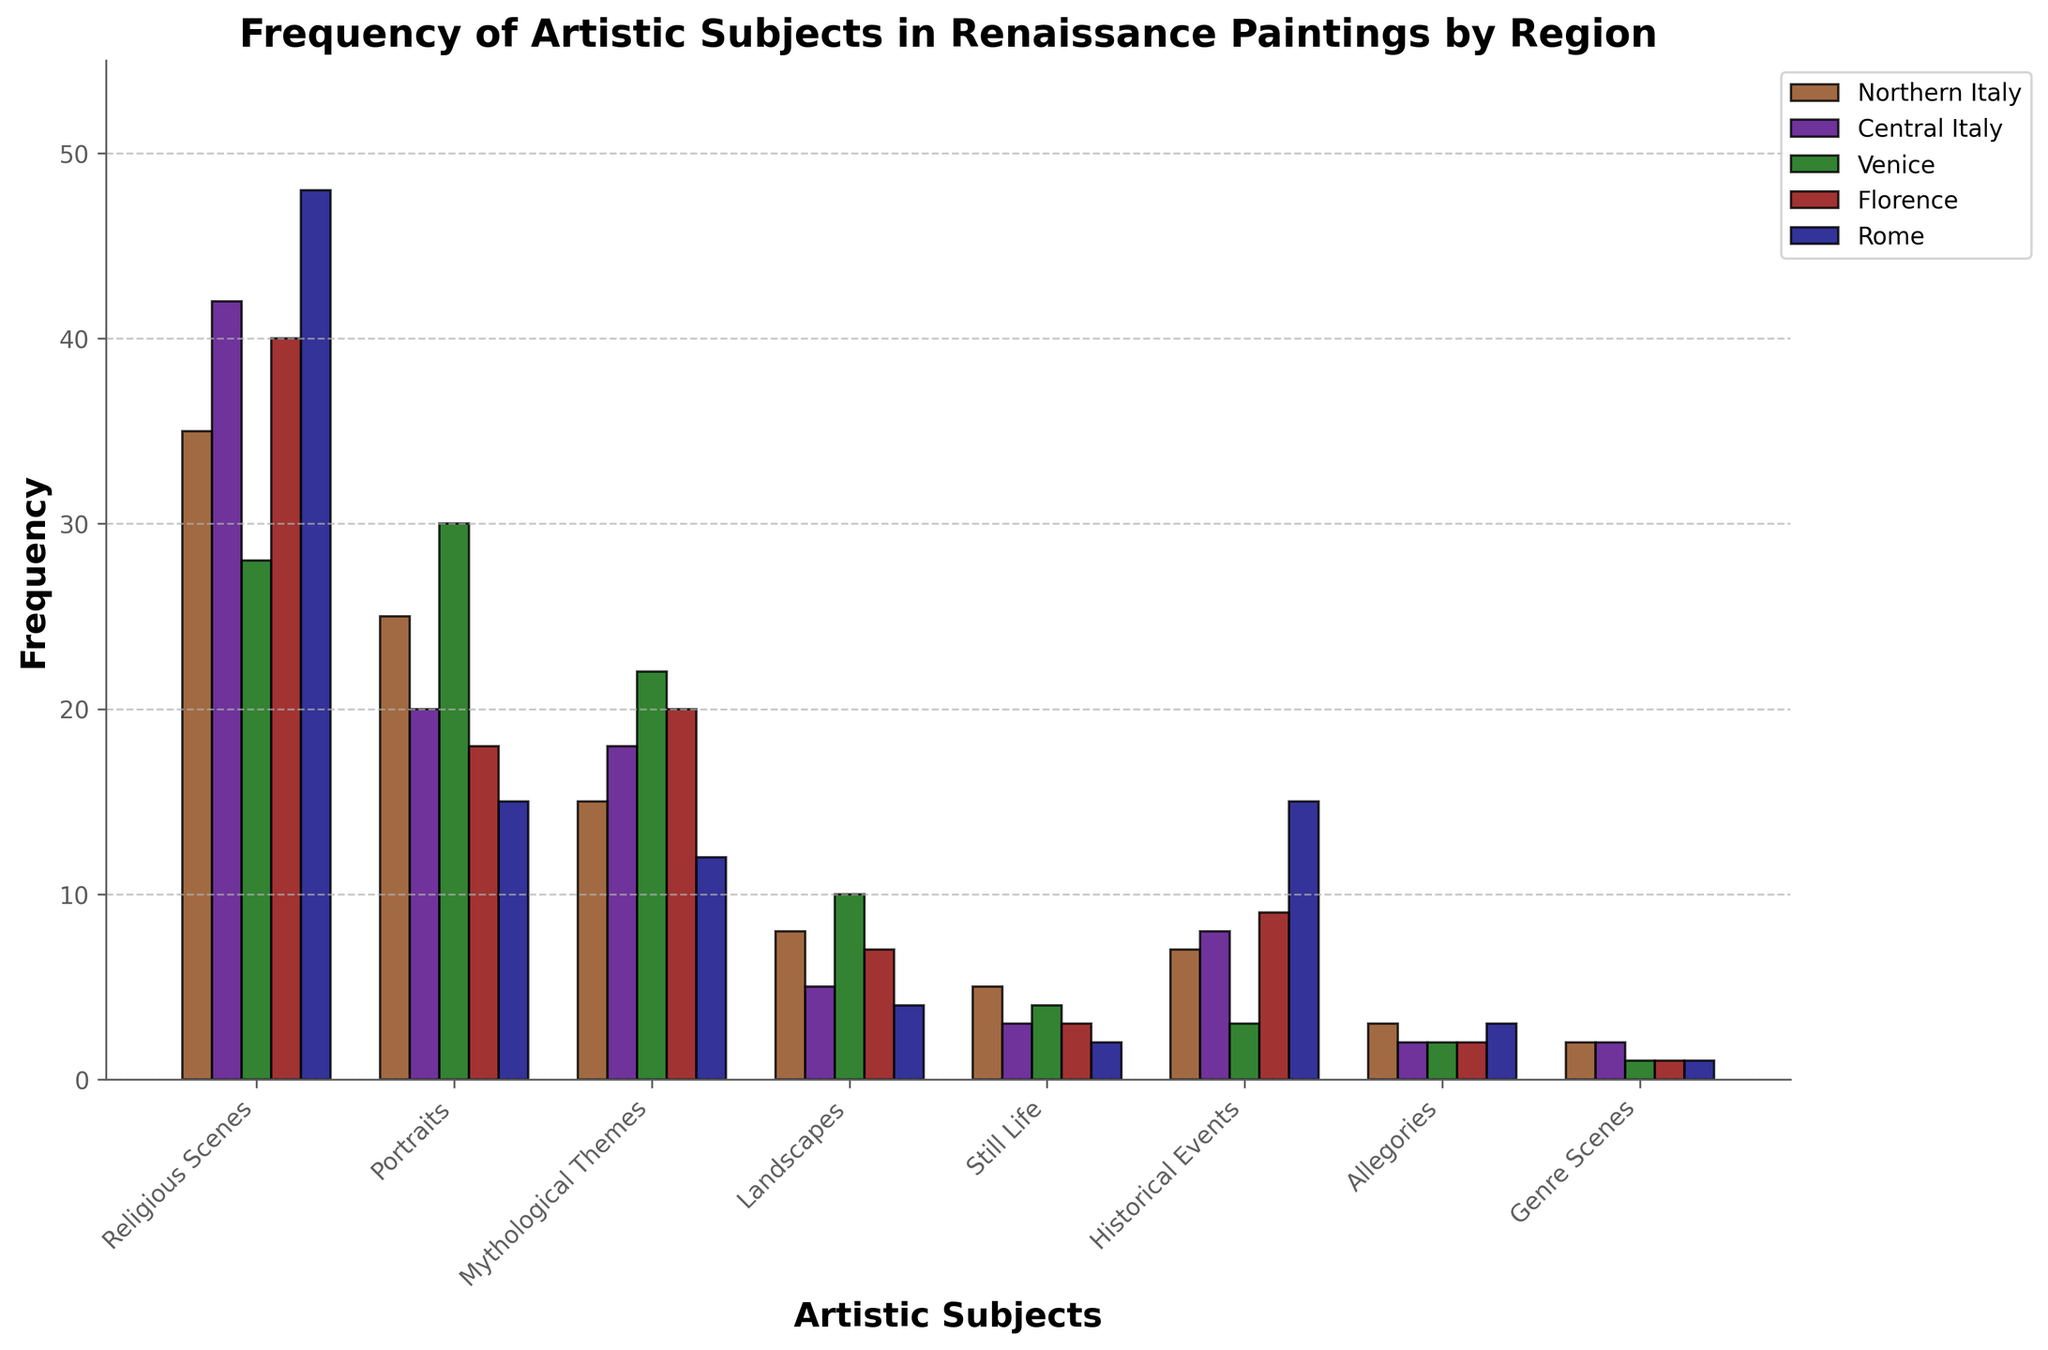What is the most frequently depicted artistic subject in Northern Italy? To find the most depicted artistic subject in Northern Italy, look for the tallest bar in the "Northern Italy" section of the chart. The highest bar corresponds to "Religious Scenes".
Answer: Religious Scenes Which region has the closest frequency of Still Life paintings to Rome? To determine which region has a close frequency of Still Life paintings to Rome, compare the height of the Still Life bars for all regions. Rome has a frequency of 2, and Central Italy also has a bar with a frequency of 3, which is the closest.
Answer: Central Italy What is the total frequency of Historical Events in Central Italy and Rome combined? To find the combined frequency, add the frequency of Historical Events in Central Italy (8) and Rome (15): 8 + 15 = 23.
Answer: 23 Which region depicts the fewest Genre Scenes? Check the height of the bars corresponding to Genre Scenes in all regions. Each region has a bar, but Venice, Florence, and Rome all depict 1 Genre Scene each, which is the fewest.
Answer: Venice, Florence, Rome What is the difference in frequency between Portraits and Landscapes in Venice? To determine the difference, find the heights of the bars for Portraits (30) and Landscapes (10) in Venice and subtract the smaller from the larger: 30 - 10 = 20.
Answer: 20 How many more Religious Scenes are depicted in Rome compared to Venice? Compare the frequency of Religious Scenes in Rome (48) and Venice (28) by subtracting the smaller value from the larger: 48 - 28 = 20.
Answer: 20 Which subject is consistently least depicted across regions? Look for the shortest bar for each region to identify the subject depicted the least. "Genre Scenes" generally has the lowest frequency across all regions.
Answer: Genre Scenes Which region has the highest total frequency of artistic subjects across all categories? Sum the frequencies of all subjects for each region and compare. The sum for Rome (48 + 15 + 12 + 4 + 2 + 15 + 3 + 1 = 100) is the highest among all regions.
Answer: Rome Which two regions have the same frequency of Artistic Subjects (same overall height) for the subject Allegories? Compare the heights of the bars for Allegories in all regions. Northern Italy and Florence both have a frequency of 2, which is the same.
Answer: Central Italy and Florence 